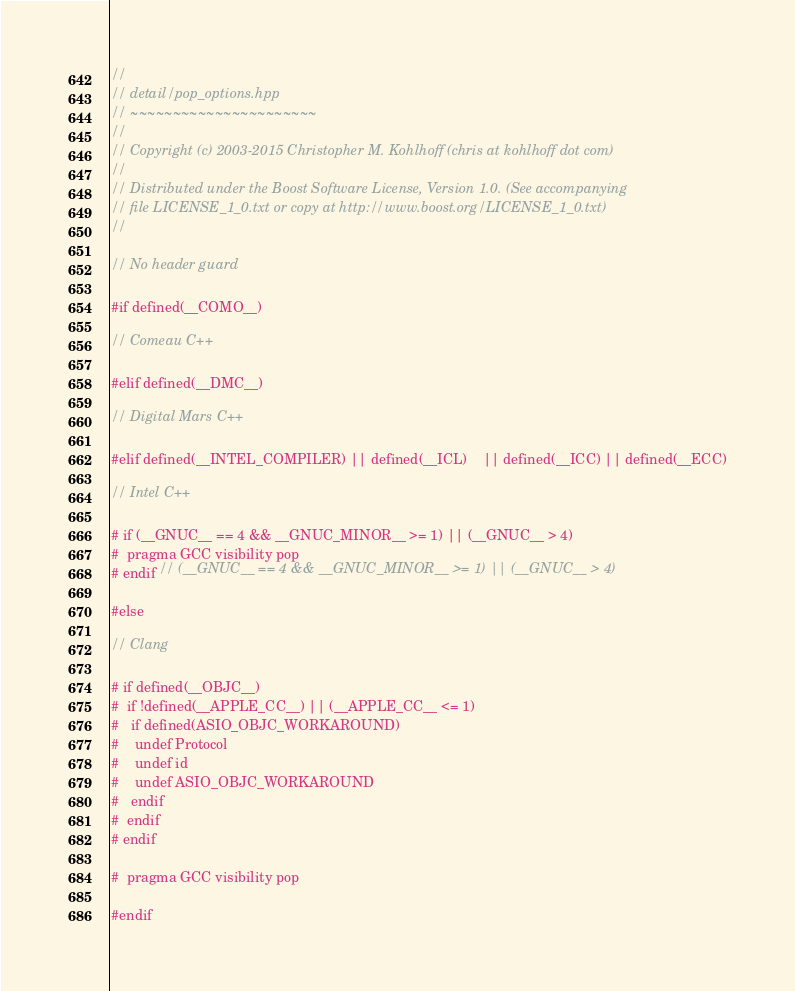Convert code to text. <code><loc_0><loc_0><loc_500><loc_500><_C++_>//
// detail/pop_options.hpp
// ~~~~~~~~~~~~~~~~~~~~~~
//
// Copyright (c) 2003-2015 Christopher M. Kohlhoff (chris at kohlhoff dot com)
//
// Distributed under the Boost Software License, Version 1.0. (See accompanying
// file LICENSE_1_0.txt or copy at http://www.boost.org/LICENSE_1_0.txt)
//

// No header guard

#if defined(__COMO__)

// Comeau C++

#elif defined(__DMC__)

// Digital Mars C++

#elif defined(__INTEL_COMPILER) || defined(__ICL)    || defined(__ICC) || defined(__ECC)

// Intel C++

# if (__GNUC__ == 4 && __GNUC_MINOR__ >= 1) || (__GNUC__ > 4)
#  pragma GCC visibility pop
# endif // (__GNUC__ == 4 && __GNUC_MINOR__ >= 1) || (__GNUC__ > 4)

#else

// Clang

# if defined(__OBJC__)
#  if !defined(__APPLE_CC__) || (__APPLE_CC__ <= 1)
#   if defined(ASIO_OBJC_WORKAROUND)
#    undef Protocol
#    undef id
#    undef ASIO_OBJC_WORKAROUND
#   endif
#  endif
# endif

#  pragma GCC visibility pop

#endif
</code> 